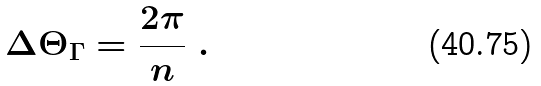Convert formula to latex. <formula><loc_0><loc_0><loc_500><loc_500>\Delta \Theta _ { \Gamma } = \frac { 2 \pi } { n } \ .</formula> 